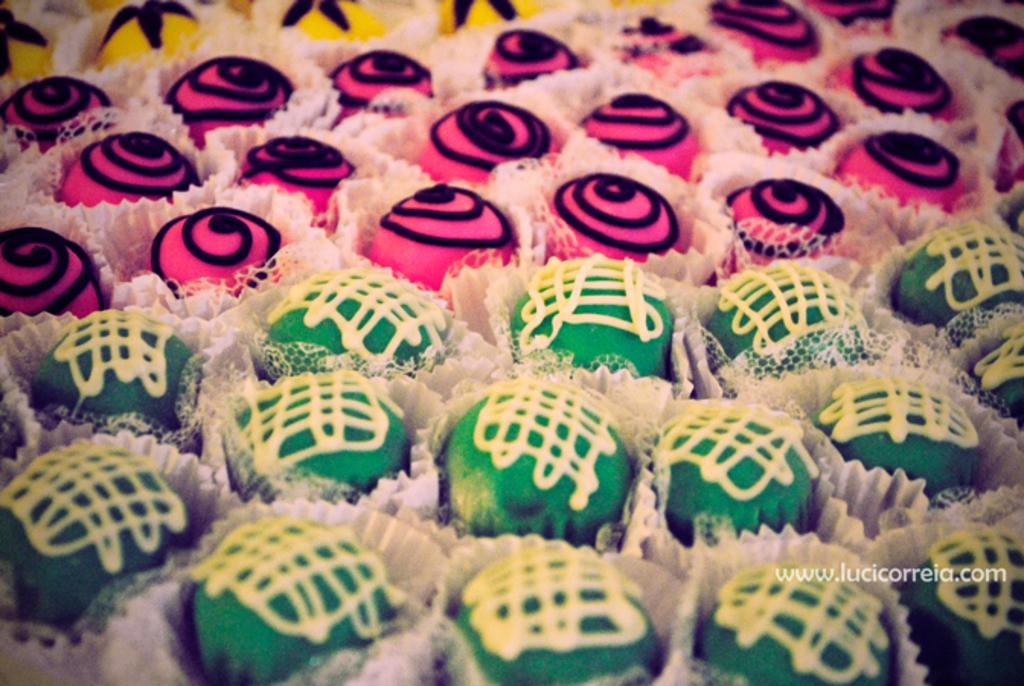What type of food is present in the image? There are cupcakes in the image. How do the cupcakes differ from one another? The cupcakes have different colors and designs. What type of kite is being used to decorate the cupcakes in the image? There is no kite present in the image; the cupcakes have different colors and designs. 